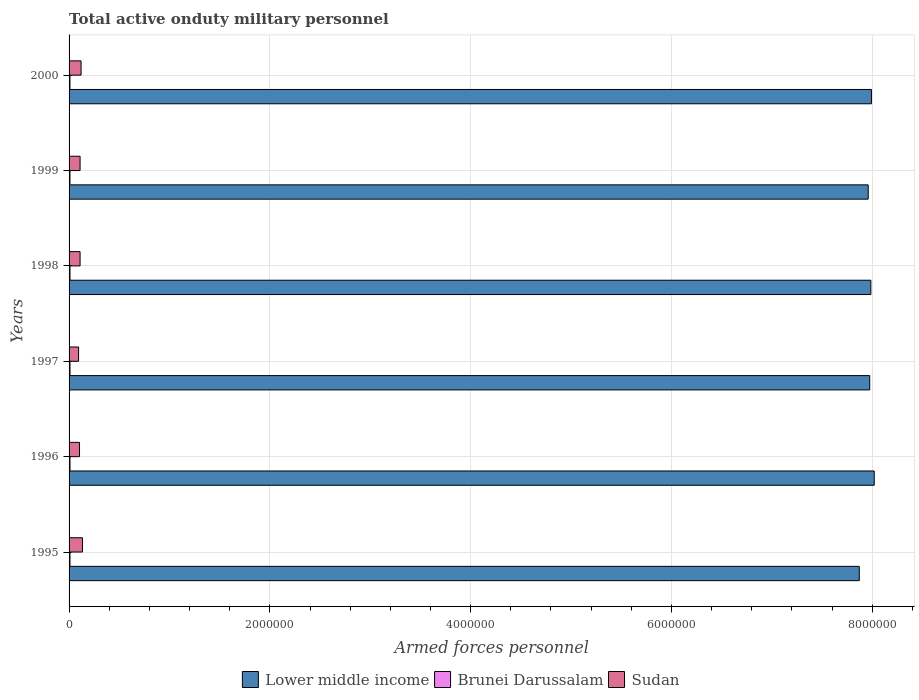How many different coloured bars are there?
Keep it short and to the point. 3. Are the number of bars per tick equal to the number of legend labels?
Keep it short and to the point. Yes. Are the number of bars on each tick of the Y-axis equal?
Your answer should be very brief. Yes. What is the label of the 5th group of bars from the top?
Your answer should be compact. 1996. What is the number of armed forces personnel in Sudan in 2000?
Your response must be concise. 1.20e+05. Across all years, what is the maximum number of armed forces personnel in Lower middle income?
Your response must be concise. 8.02e+06. Across all years, what is the minimum number of armed forces personnel in Brunei Darussalam?
Offer a terse response. 8750. In which year was the number of armed forces personnel in Brunei Darussalam maximum?
Make the answer very short. 1996. What is the total number of armed forces personnel in Lower middle income in the graph?
Your response must be concise. 4.78e+07. What is the difference between the number of armed forces personnel in Brunei Darussalam in 1998 and that in 1999?
Your answer should be compact. 300. What is the difference between the number of armed forces personnel in Lower middle income in 2000 and the number of armed forces personnel in Brunei Darussalam in 1998?
Ensure brevity in your answer.  7.98e+06. What is the average number of armed forces personnel in Brunei Darussalam per year?
Provide a short and direct response. 8958.33. In the year 2000, what is the difference between the number of armed forces personnel in Sudan and number of armed forces personnel in Lower middle income?
Make the answer very short. -7.87e+06. What is the ratio of the number of armed forces personnel in Lower middle income in 1995 to that in 2000?
Your answer should be very brief. 0.98. Is the number of armed forces personnel in Brunei Darussalam in 1998 less than that in 2000?
Provide a succinct answer. No. Is the difference between the number of armed forces personnel in Sudan in 1998 and 2000 greater than the difference between the number of armed forces personnel in Lower middle income in 1998 and 2000?
Ensure brevity in your answer.  No. What is the difference between the highest and the second highest number of armed forces personnel in Brunei Darussalam?
Keep it short and to the point. 50. What is the difference between the highest and the lowest number of armed forces personnel in Brunei Darussalam?
Provide a succinct answer. 350. In how many years, is the number of armed forces personnel in Brunei Darussalam greater than the average number of armed forces personnel in Brunei Darussalam taken over all years?
Provide a succinct answer. 4. What does the 2nd bar from the top in 1996 represents?
Offer a terse response. Brunei Darussalam. What does the 1st bar from the bottom in 1998 represents?
Your response must be concise. Lower middle income. Is it the case that in every year, the sum of the number of armed forces personnel in Lower middle income and number of armed forces personnel in Sudan is greater than the number of armed forces personnel in Brunei Darussalam?
Your answer should be compact. Yes. How many bars are there?
Keep it short and to the point. 18. How many years are there in the graph?
Keep it short and to the point. 6. What is the difference between two consecutive major ticks on the X-axis?
Provide a short and direct response. 2.00e+06. Are the values on the major ticks of X-axis written in scientific E-notation?
Offer a terse response. No. Does the graph contain any zero values?
Provide a short and direct response. No. Does the graph contain grids?
Your response must be concise. Yes. Where does the legend appear in the graph?
Your response must be concise. Bottom center. What is the title of the graph?
Give a very brief answer. Total active onduty military personnel. Does "China" appear as one of the legend labels in the graph?
Keep it short and to the point. No. What is the label or title of the X-axis?
Your answer should be very brief. Armed forces personnel. What is the Armed forces personnel in Lower middle income in 1995?
Your response must be concise. 7.87e+06. What is the Armed forces personnel of Brunei Darussalam in 1995?
Your response must be concise. 9000. What is the Armed forces personnel of Sudan in 1995?
Your response must be concise. 1.34e+05. What is the Armed forces personnel in Lower middle income in 1996?
Keep it short and to the point. 8.02e+06. What is the Armed forces personnel of Brunei Darussalam in 1996?
Your answer should be very brief. 9100. What is the Armed forces personnel of Sudan in 1996?
Your response must be concise. 1.04e+05. What is the Armed forces personnel in Lower middle income in 1997?
Make the answer very short. 7.98e+06. What is the Armed forces personnel in Brunei Darussalam in 1997?
Offer a very short reply. 9050. What is the Armed forces personnel of Sudan in 1997?
Your answer should be very brief. 9.47e+04. What is the Armed forces personnel in Lower middle income in 1998?
Provide a short and direct response. 7.99e+06. What is the Armed forces personnel in Brunei Darussalam in 1998?
Offer a terse response. 9050. What is the Armed forces personnel of Sudan in 1998?
Provide a succinct answer. 1.10e+05. What is the Armed forces personnel in Lower middle income in 1999?
Provide a short and direct response. 7.96e+06. What is the Armed forces personnel of Brunei Darussalam in 1999?
Provide a short and direct response. 8750. What is the Armed forces personnel of Sudan in 1999?
Make the answer very short. 1.10e+05. What is the Armed forces personnel in Lower middle income in 2000?
Your answer should be compact. 7.99e+06. What is the Armed forces personnel in Brunei Darussalam in 2000?
Your answer should be very brief. 8800. What is the Armed forces personnel of Sudan in 2000?
Keep it short and to the point. 1.20e+05. Across all years, what is the maximum Armed forces personnel of Lower middle income?
Provide a short and direct response. 8.02e+06. Across all years, what is the maximum Armed forces personnel of Brunei Darussalam?
Keep it short and to the point. 9100. Across all years, what is the maximum Armed forces personnel of Sudan?
Provide a short and direct response. 1.34e+05. Across all years, what is the minimum Armed forces personnel in Lower middle income?
Your response must be concise. 7.87e+06. Across all years, what is the minimum Armed forces personnel of Brunei Darussalam?
Offer a very short reply. 8750. Across all years, what is the minimum Armed forces personnel of Sudan?
Make the answer very short. 9.47e+04. What is the total Armed forces personnel of Lower middle income in the graph?
Provide a short and direct response. 4.78e+07. What is the total Armed forces personnel of Brunei Darussalam in the graph?
Your response must be concise. 5.38e+04. What is the total Armed forces personnel of Sudan in the graph?
Your response must be concise. 6.71e+05. What is the difference between the Armed forces personnel of Lower middle income in 1995 and that in 1996?
Provide a succinct answer. -1.49e+05. What is the difference between the Armed forces personnel in Brunei Darussalam in 1995 and that in 1996?
Your answer should be very brief. -100. What is the difference between the Armed forces personnel in Sudan in 1995 and that in 1996?
Ensure brevity in your answer.  2.95e+04. What is the difference between the Armed forces personnel of Lower middle income in 1995 and that in 1997?
Offer a very short reply. -1.04e+05. What is the difference between the Armed forces personnel in Brunei Darussalam in 1995 and that in 1997?
Ensure brevity in your answer.  -50. What is the difference between the Armed forces personnel in Sudan in 1995 and that in 1997?
Provide a succinct answer. 3.88e+04. What is the difference between the Armed forces personnel in Lower middle income in 1995 and that in 1998?
Ensure brevity in your answer.  -1.15e+05. What is the difference between the Armed forces personnel of Sudan in 1995 and that in 1998?
Provide a succinct answer. 2.38e+04. What is the difference between the Armed forces personnel in Lower middle income in 1995 and that in 1999?
Offer a terse response. -8.88e+04. What is the difference between the Armed forces personnel in Brunei Darussalam in 1995 and that in 1999?
Your answer should be very brief. 250. What is the difference between the Armed forces personnel of Sudan in 1995 and that in 1999?
Provide a short and direct response. 2.38e+04. What is the difference between the Armed forces personnel of Lower middle income in 1995 and that in 2000?
Provide a short and direct response. -1.21e+05. What is the difference between the Armed forces personnel of Sudan in 1995 and that in 2000?
Your answer should be compact. 1.40e+04. What is the difference between the Armed forces personnel of Lower middle income in 1996 and that in 1997?
Provide a short and direct response. 4.48e+04. What is the difference between the Armed forces personnel in Sudan in 1996 and that in 1997?
Provide a short and direct response. 9300. What is the difference between the Armed forces personnel in Lower middle income in 1996 and that in 1998?
Your response must be concise. 3.36e+04. What is the difference between the Armed forces personnel in Sudan in 1996 and that in 1998?
Offer a terse response. -5700. What is the difference between the Armed forces personnel in Lower middle income in 1996 and that in 1999?
Provide a succinct answer. 6.01e+04. What is the difference between the Armed forces personnel of Brunei Darussalam in 1996 and that in 1999?
Give a very brief answer. 350. What is the difference between the Armed forces personnel of Sudan in 1996 and that in 1999?
Provide a succinct answer. -5700. What is the difference between the Armed forces personnel of Lower middle income in 1996 and that in 2000?
Offer a very short reply. 2.78e+04. What is the difference between the Armed forces personnel of Brunei Darussalam in 1996 and that in 2000?
Provide a succinct answer. 300. What is the difference between the Armed forces personnel in Sudan in 1996 and that in 2000?
Provide a short and direct response. -1.55e+04. What is the difference between the Armed forces personnel of Lower middle income in 1997 and that in 1998?
Your response must be concise. -1.12e+04. What is the difference between the Armed forces personnel of Sudan in 1997 and that in 1998?
Make the answer very short. -1.50e+04. What is the difference between the Armed forces personnel of Lower middle income in 1997 and that in 1999?
Keep it short and to the point. 1.53e+04. What is the difference between the Armed forces personnel in Brunei Darussalam in 1997 and that in 1999?
Offer a terse response. 300. What is the difference between the Armed forces personnel in Sudan in 1997 and that in 1999?
Your answer should be compact. -1.50e+04. What is the difference between the Armed forces personnel of Lower middle income in 1997 and that in 2000?
Your response must be concise. -1.71e+04. What is the difference between the Armed forces personnel in Brunei Darussalam in 1997 and that in 2000?
Offer a very short reply. 250. What is the difference between the Armed forces personnel in Sudan in 1997 and that in 2000?
Provide a short and direct response. -2.48e+04. What is the difference between the Armed forces personnel in Lower middle income in 1998 and that in 1999?
Give a very brief answer. 2.64e+04. What is the difference between the Armed forces personnel of Brunei Darussalam in 1998 and that in 1999?
Your answer should be compact. 300. What is the difference between the Armed forces personnel in Sudan in 1998 and that in 1999?
Provide a succinct answer. 0. What is the difference between the Armed forces personnel in Lower middle income in 1998 and that in 2000?
Provide a short and direct response. -5900. What is the difference between the Armed forces personnel in Brunei Darussalam in 1998 and that in 2000?
Make the answer very short. 250. What is the difference between the Armed forces personnel in Sudan in 1998 and that in 2000?
Your answer should be compact. -9800. What is the difference between the Armed forces personnel of Lower middle income in 1999 and that in 2000?
Offer a very short reply. -3.24e+04. What is the difference between the Armed forces personnel of Sudan in 1999 and that in 2000?
Keep it short and to the point. -9800. What is the difference between the Armed forces personnel in Lower middle income in 1995 and the Armed forces personnel in Brunei Darussalam in 1996?
Offer a terse response. 7.86e+06. What is the difference between the Armed forces personnel in Lower middle income in 1995 and the Armed forces personnel in Sudan in 1996?
Give a very brief answer. 7.77e+06. What is the difference between the Armed forces personnel of Brunei Darussalam in 1995 and the Armed forces personnel of Sudan in 1996?
Give a very brief answer. -9.50e+04. What is the difference between the Armed forces personnel of Lower middle income in 1995 and the Armed forces personnel of Brunei Darussalam in 1997?
Make the answer very short. 7.86e+06. What is the difference between the Armed forces personnel in Lower middle income in 1995 and the Armed forces personnel in Sudan in 1997?
Provide a short and direct response. 7.78e+06. What is the difference between the Armed forces personnel in Brunei Darussalam in 1995 and the Armed forces personnel in Sudan in 1997?
Provide a succinct answer. -8.57e+04. What is the difference between the Armed forces personnel of Lower middle income in 1995 and the Armed forces personnel of Brunei Darussalam in 1998?
Your response must be concise. 7.86e+06. What is the difference between the Armed forces personnel of Lower middle income in 1995 and the Armed forces personnel of Sudan in 1998?
Your answer should be compact. 7.76e+06. What is the difference between the Armed forces personnel in Brunei Darussalam in 1995 and the Armed forces personnel in Sudan in 1998?
Provide a short and direct response. -1.01e+05. What is the difference between the Armed forces personnel of Lower middle income in 1995 and the Armed forces personnel of Brunei Darussalam in 1999?
Make the answer very short. 7.86e+06. What is the difference between the Armed forces personnel of Lower middle income in 1995 and the Armed forces personnel of Sudan in 1999?
Provide a succinct answer. 7.76e+06. What is the difference between the Armed forces personnel of Brunei Darussalam in 1995 and the Armed forces personnel of Sudan in 1999?
Your answer should be compact. -1.01e+05. What is the difference between the Armed forces personnel of Lower middle income in 1995 and the Armed forces personnel of Brunei Darussalam in 2000?
Give a very brief answer. 7.86e+06. What is the difference between the Armed forces personnel in Lower middle income in 1995 and the Armed forces personnel in Sudan in 2000?
Keep it short and to the point. 7.75e+06. What is the difference between the Armed forces personnel of Brunei Darussalam in 1995 and the Armed forces personnel of Sudan in 2000?
Provide a succinct answer. -1.10e+05. What is the difference between the Armed forces personnel in Lower middle income in 1996 and the Armed forces personnel in Brunei Darussalam in 1997?
Your answer should be very brief. 8.01e+06. What is the difference between the Armed forces personnel of Lower middle income in 1996 and the Armed forces personnel of Sudan in 1997?
Offer a terse response. 7.93e+06. What is the difference between the Armed forces personnel in Brunei Darussalam in 1996 and the Armed forces personnel in Sudan in 1997?
Give a very brief answer. -8.56e+04. What is the difference between the Armed forces personnel in Lower middle income in 1996 and the Armed forces personnel in Brunei Darussalam in 1998?
Ensure brevity in your answer.  8.01e+06. What is the difference between the Armed forces personnel of Lower middle income in 1996 and the Armed forces personnel of Sudan in 1998?
Ensure brevity in your answer.  7.91e+06. What is the difference between the Armed forces personnel of Brunei Darussalam in 1996 and the Armed forces personnel of Sudan in 1998?
Make the answer very short. -1.01e+05. What is the difference between the Armed forces personnel in Lower middle income in 1996 and the Armed forces personnel in Brunei Darussalam in 1999?
Offer a very short reply. 8.01e+06. What is the difference between the Armed forces personnel in Lower middle income in 1996 and the Armed forces personnel in Sudan in 1999?
Your response must be concise. 7.91e+06. What is the difference between the Armed forces personnel of Brunei Darussalam in 1996 and the Armed forces personnel of Sudan in 1999?
Keep it short and to the point. -1.01e+05. What is the difference between the Armed forces personnel in Lower middle income in 1996 and the Armed forces personnel in Brunei Darussalam in 2000?
Your answer should be compact. 8.01e+06. What is the difference between the Armed forces personnel of Lower middle income in 1996 and the Armed forces personnel of Sudan in 2000?
Ensure brevity in your answer.  7.90e+06. What is the difference between the Armed forces personnel in Brunei Darussalam in 1996 and the Armed forces personnel in Sudan in 2000?
Offer a very short reply. -1.10e+05. What is the difference between the Armed forces personnel in Lower middle income in 1997 and the Armed forces personnel in Brunei Darussalam in 1998?
Ensure brevity in your answer.  7.97e+06. What is the difference between the Armed forces personnel of Lower middle income in 1997 and the Armed forces personnel of Sudan in 1998?
Offer a terse response. 7.87e+06. What is the difference between the Armed forces personnel in Brunei Darussalam in 1997 and the Armed forces personnel in Sudan in 1998?
Give a very brief answer. -1.01e+05. What is the difference between the Armed forces personnel in Lower middle income in 1997 and the Armed forces personnel in Brunei Darussalam in 1999?
Ensure brevity in your answer.  7.97e+06. What is the difference between the Armed forces personnel in Lower middle income in 1997 and the Armed forces personnel in Sudan in 1999?
Offer a very short reply. 7.87e+06. What is the difference between the Armed forces personnel of Brunei Darussalam in 1997 and the Armed forces personnel of Sudan in 1999?
Provide a short and direct response. -1.01e+05. What is the difference between the Armed forces personnel in Lower middle income in 1997 and the Armed forces personnel in Brunei Darussalam in 2000?
Your response must be concise. 7.97e+06. What is the difference between the Armed forces personnel in Lower middle income in 1997 and the Armed forces personnel in Sudan in 2000?
Ensure brevity in your answer.  7.86e+06. What is the difference between the Armed forces personnel of Brunei Darussalam in 1997 and the Armed forces personnel of Sudan in 2000?
Make the answer very short. -1.10e+05. What is the difference between the Armed forces personnel in Lower middle income in 1998 and the Armed forces personnel in Brunei Darussalam in 1999?
Offer a terse response. 7.98e+06. What is the difference between the Armed forces personnel in Lower middle income in 1998 and the Armed forces personnel in Sudan in 1999?
Your answer should be very brief. 7.88e+06. What is the difference between the Armed forces personnel in Brunei Darussalam in 1998 and the Armed forces personnel in Sudan in 1999?
Offer a terse response. -1.01e+05. What is the difference between the Armed forces personnel in Lower middle income in 1998 and the Armed forces personnel in Brunei Darussalam in 2000?
Make the answer very short. 7.98e+06. What is the difference between the Armed forces personnel in Lower middle income in 1998 and the Armed forces personnel in Sudan in 2000?
Offer a terse response. 7.87e+06. What is the difference between the Armed forces personnel in Brunei Darussalam in 1998 and the Armed forces personnel in Sudan in 2000?
Offer a very short reply. -1.10e+05. What is the difference between the Armed forces personnel of Lower middle income in 1999 and the Armed forces personnel of Brunei Darussalam in 2000?
Your answer should be very brief. 7.95e+06. What is the difference between the Armed forces personnel in Lower middle income in 1999 and the Armed forces personnel in Sudan in 2000?
Give a very brief answer. 7.84e+06. What is the difference between the Armed forces personnel of Brunei Darussalam in 1999 and the Armed forces personnel of Sudan in 2000?
Offer a terse response. -1.11e+05. What is the average Armed forces personnel in Lower middle income per year?
Your answer should be very brief. 7.97e+06. What is the average Armed forces personnel in Brunei Darussalam per year?
Your answer should be compact. 8958.33. What is the average Armed forces personnel in Sudan per year?
Ensure brevity in your answer.  1.12e+05. In the year 1995, what is the difference between the Armed forces personnel of Lower middle income and Armed forces personnel of Brunei Darussalam?
Give a very brief answer. 7.86e+06. In the year 1995, what is the difference between the Armed forces personnel of Lower middle income and Armed forces personnel of Sudan?
Make the answer very short. 7.74e+06. In the year 1995, what is the difference between the Armed forces personnel in Brunei Darussalam and Armed forces personnel in Sudan?
Make the answer very short. -1.24e+05. In the year 1996, what is the difference between the Armed forces personnel of Lower middle income and Armed forces personnel of Brunei Darussalam?
Give a very brief answer. 8.01e+06. In the year 1996, what is the difference between the Armed forces personnel of Lower middle income and Armed forces personnel of Sudan?
Your answer should be compact. 7.92e+06. In the year 1996, what is the difference between the Armed forces personnel of Brunei Darussalam and Armed forces personnel of Sudan?
Provide a short and direct response. -9.49e+04. In the year 1997, what is the difference between the Armed forces personnel of Lower middle income and Armed forces personnel of Brunei Darussalam?
Keep it short and to the point. 7.97e+06. In the year 1997, what is the difference between the Armed forces personnel of Lower middle income and Armed forces personnel of Sudan?
Make the answer very short. 7.88e+06. In the year 1997, what is the difference between the Armed forces personnel of Brunei Darussalam and Armed forces personnel of Sudan?
Provide a short and direct response. -8.56e+04. In the year 1998, what is the difference between the Armed forces personnel in Lower middle income and Armed forces personnel in Brunei Darussalam?
Your answer should be very brief. 7.98e+06. In the year 1998, what is the difference between the Armed forces personnel of Lower middle income and Armed forces personnel of Sudan?
Your answer should be compact. 7.88e+06. In the year 1998, what is the difference between the Armed forces personnel in Brunei Darussalam and Armed forces personnel in Sudan?
Keep it short and to the point. -1.01e+05. In the year 1999, what is the difference between the Armed forces personnel in Lower middle income and Armed forces personnel in Brunei Darussalam?
Give a very brief answer. 7.95e+06. In the year 1999, what is the difference between the Armed forces personnel of Lower middle income and Armed forces personnel of Sudan?
Your answer should be very brief. 7.85e+06. In the year 1999, what is the difference between the Armed forces personnel in Brunei Darussalam and Armed forces personnel in Sudan?
Give a very brief answer. -1.01e+05. In the year 2000, what is the difference between the Armed forces personnel in Lower middle income and Armed forces personnel in Brunei Darussalam?
Your answer should be compact. 7.98e+06. In the year 2000, what is the difference between the Armed forces personnel of Lower middle income and Armed forces personnel of Sudan?
Provide a succinct answer. 7.87e+06. In the year 2000, what is the difference between the Armed forces personnel in Brunei Darussalam and Armed forces personnel in Sudan?
Make the answer very short. -1.11e+05. What is the ratio of the Armed forces personnel in Lower middle income in 1995 to that in 1996?
Give a very brief answer. 0.98. What is the ratio of the Armed forces personnel of Sudan in 1995 to that in 1996?
Ensure brevity in your answer.  1.28. What is the ratio of the Armed forces personnel in Brunei Darussalam in 1995 to that in 1997?
Provide a short and direct response. 0.99. What is the ratio of the Armed forces personnel in Sudan in 1995 to that in 1997?
Make the answer very short. 1.41. What is the ratio of the Armed forces personnel of Lower middle income in 1995 to that in 1998?
Ensure brevity in your answer.  0.99. What is the ratio of the Armed forces personnel of Sudan in 1995 to that in 1998?
Your response must be concise. 1.22. What is the ratio of the Armed forces personnel of Brunei Darussalam in 1995 to that in 1999?
Provide a succinct answer. 1.03. What is the ratio of the Armed forces personnel in Sudan in 1995 to that in 1999?
Your response must be concise. 1.22. What is the ratio of the Armed forces personnel in Lower middle income in 1995 to that in 2000?
Offer a very short reply. 0.98. What is the ratio of the Armed forces personnel in Brunei Darussalam in 1995 to that in 2000?
Your response must be concise. 1.02. What is the ratio of the Armed forces personnel in Sudan in 1995 to that in 2000?
Keep it short and to the point. 1.12. What is the ratio of the Armed forces personnel of Lower middle income in 1996 to that in 1997?
Give a very brief answer. 1.01. What is the ratio of the Armed forces personnel of Brunei Darussalam in 1996 to that in 1997?
Keep it short and to the point. 1.01. What is the ratio of the Armed forces personnel in Sudan in 1996 to that in 1997?
Your response must be concise. 1.1. What is the ratio of the Armed forces personnel in Lower middle income in 1996 to that in 1998?
Your answer should be very brief. 1. What is the ratio of the Armed forces personnel of Sudan in 1996 to that in 1998?
Offer a terse response. 0.95. What is the ratio of the Armed forces personnel of Lower middle income in 1996 to that in 1999?
Make the answer very short. 1.01. What is the ratio of the Armed forces personnel in Brunei Darussalam in 1996 to that in 1999?
Keep it short and to the point. 1.04. What is the ratio of the Armed forces personnel in Sudan in 1996 to that in 1999?
Ensure brevity in your answer.  0.95. What is the ratio of the Armed forces personnel in Lower middle income in 1996 to that in 2000?
Provide a short and direct response. 1. What is the ratio of the Armed forces personnel of Brunei Darussalam in 1996 to that in 2000?
Your response must be concise. 1.03. What is the ratio of the Armed forces personnel of Sudan in 1996 to that in 2000?
Provide a short and direct response. 0.87. What is the ratio of the Armed forces personnel in Lower middle income in 1997 to that in 1998?
Keep it short and to the point. 1. What is the ratio of the Armed forces personnel of Sudan in 1997 to that in 1998?
Your answer should be very brief. 0.86. What is the ratio of the Armed forces personnel of Lower middle income in 1997 to that in 1999?
Provide a succinct answer. 1. What is the ratio of the Armed forces personnel in Brunei Darussalam in 1997 to that in 1999?
Make the answer very short. 1.03. What is the ratio of the Armed forces personnel in Sudan in 1997 to that in 1999?
Provide a succinct answer. 0.86. What is the ratio of the Armed forces personnel in Lower middle income in 1997 to that in 2000?
Your answer should be very brief. 1. What is the ratio of the Armed forces personnel of Brunei Darussalam in 1997 to that in 2000?
Keep it short and to the point. 1.03. What is the ratio of the Armed forces personnel in Sudan in 1997 to that in 2000?
Give a very brief answer. 0.79. What is the ratio of the Armed forces personnel in Lower middle income in 1998 to that in 1999?
Keep it short and to the point. 1. What is the ratio of the Armed forces personnel of Brunei Darussalam in 1998 to that in 1999?
Provide a short and direct response. 1.03. What is the ratio of the Armed forces personnel in Lower middle income in 1998 to that in 2000?
Your answer should be compact. 1. What is the ratio of the Armed forces personnel of Brunei Darussalam in 1998 to that in 2000?
Your answer should be very brief. 1.03. What is the ratio of the Armed forces personnel of Sudan in 1998 to that in 2000?
Your response must be concise. 0.92. What is the ratio of the Armed forces personnel in Brunei Darussalam in 1999 to that in 2000?
Provide a short and direct response. 0.99. What is the ratio of the Armed forces personnel of Sudan in 1999 to that in 2000?
Ensure brevity in your answer.  0.92. What is the difference between the highest and the second highest Armed forces personnel of Lower middle income?
Your answer should be very brief. 2.78e+04. What is the difference between the highest and the second highest Armed forces personnel of Brunei Darussalam?
Your answer should be very brief. 50. What is the difference between the highest and the second highest Armed forces personnel in Sudan?
Ensure brevity in your answer.  1.40e+04. What is the difference between the highest and the lowest Armed forces personnel of Lower middle income?
Your answer should be very brief. 1.49e+05. What is the difference between the highest and the lowest Armed forces personnel in Brunei Darussalam?
Your answer should be compact. 350. What is the difference between the highest and the lowest Armed forces personnel in Sudan?
Give a very brief answer. 3.88e+04. 